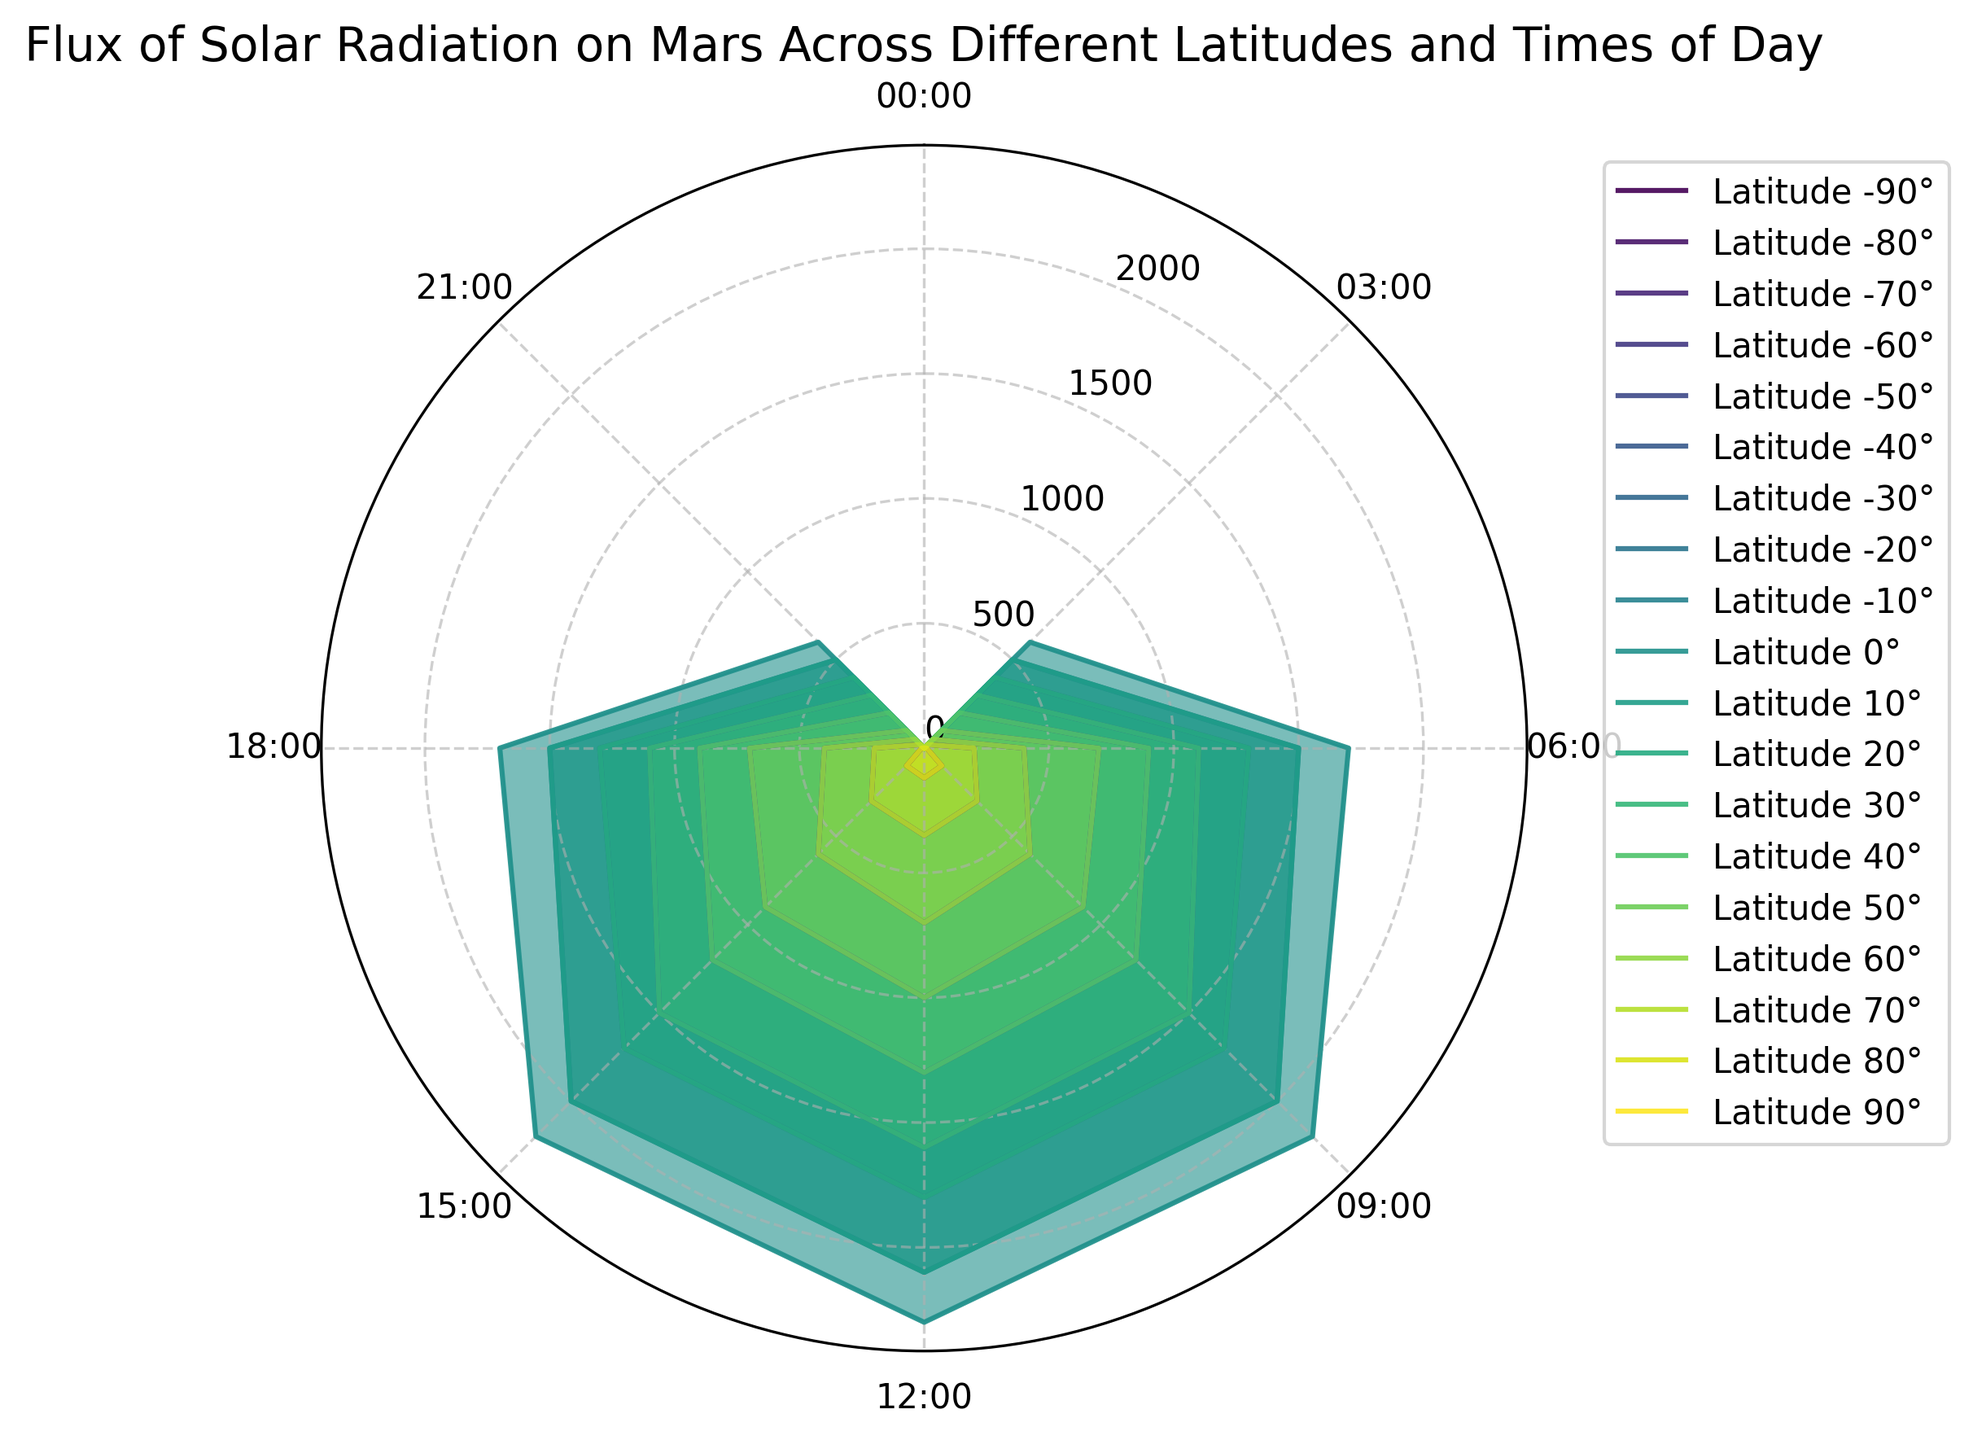What is the peak solar flux at the equator (0° latitude) during the day? Locate the equator (0° latitude) on the figure and look for the highest vertical extension of the transparency and line representing the solar flux. The maximum value is at 12:00, where the flux reaches 2300
Answer: 2300 At which time of day does the -80° latitude receive the highest solar flux, and what is its value? Identify the shaded region and line for -80° latitude and trace the peaks. The highest point occurs at 12:00 with a solar flux of 120
Answer: 12:00, 120 How does the solar flux at 3:00 compare between latitudes 20° and -30°? Find the angle representing 3:00 on the figure and compare the lengths of the corresponding solar flux lines. Latitude 20° has a solar flux of 400, while -30° has a solar flux of 300
Answer: Greater at 20°, 400 vs 300 Which latitude shows the most significant variation in solar flux throughout the day? Observe the range of solar flux values across latitudes. The latitude with the largest difference between the highest and lowest points has the most significant variation. The equator (0° latitude) shows the most considerable variation (from 0 to 2300)
Answer: Equator (0°) Does any latitude have a solar flux of zero throughout the day? If so, which latitude(s)? Look for any regions on the plot that remain flat at the zero mark across all times of the day. Both ±90° latitudes meet this criterion
Answer: ±90° Compare the solar flux at midday (12:00) between latitudes 40° and -50°. What can be inferred? Locate the 12:00 label and check the lengths of the transparency and lines for 40° and -50° latitudes. Both latitudes show a similar pattern with close flux values of 1300 and 1000, respectively
Answer: 40° is higher, 1300 vs 1000 What is the average solar flux at 9:00 for latitudes from -20° to 20°? Collect the solar flux values at 9:00 for latitudes -20°, -10°, 0°, 10°, and 20°. Add these values (1700+2000+2200+2000+1700) and divide by the number of data points. The average is 9600/5
Answer: 1920 Is there a significant difference in peak solar flux between northern and southern latitudes? Provide specific examples. Compare one northern latitude with its corresponding southern latitude (e.g., 10° and -10°). Check the highest flux values during the day, which are both around 2100 at 12:00. No significant difference is observed
Answer: No significant difference 